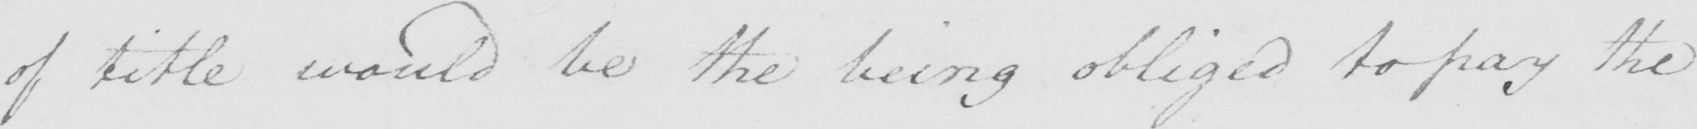What text is written in this handwritten line? of title would be the being obliged to pay the 